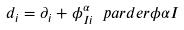<formula> <loc_0><loc_0><loc_500><loc_500>d _ { i } = \partial _ { i } + \phi ^ { \alpha } _ { I i } \ p a r d e r { } { \phi } { \alpha } { I }</formula> 